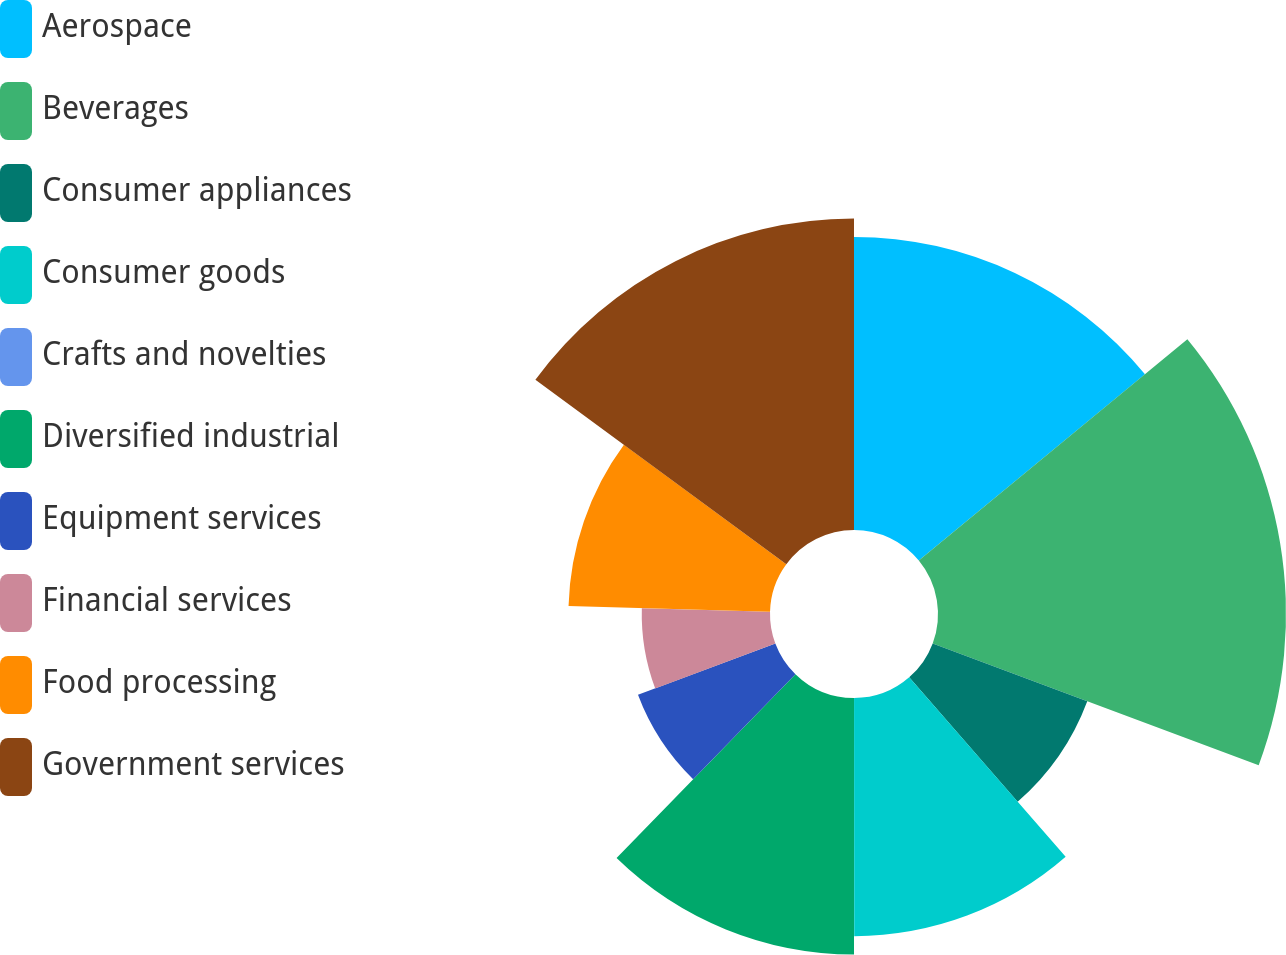Convert chart to OTSL. <chart><loc_0><loc_0><loc_500><loc_500><pie_chart><fcel>Aerospace<fcel>Beverages<fcel>Consumer appliances<fcel>Consumer goods<fcel>Crafts and novelties<fcel>Diversified industrial<fcel>Equipment services<fcel>Financial services<fcel>Food processing<fcel>Government services<nl><fcel>14.03%<fcel>16.66%<fcel>7.9%<fcel>11.4%<fcel>0.01%<fcel>12.28%<fcel>7.02%<fcel>6.14%<fcel>9.65%<fcel>14.91%<nl></chart> 